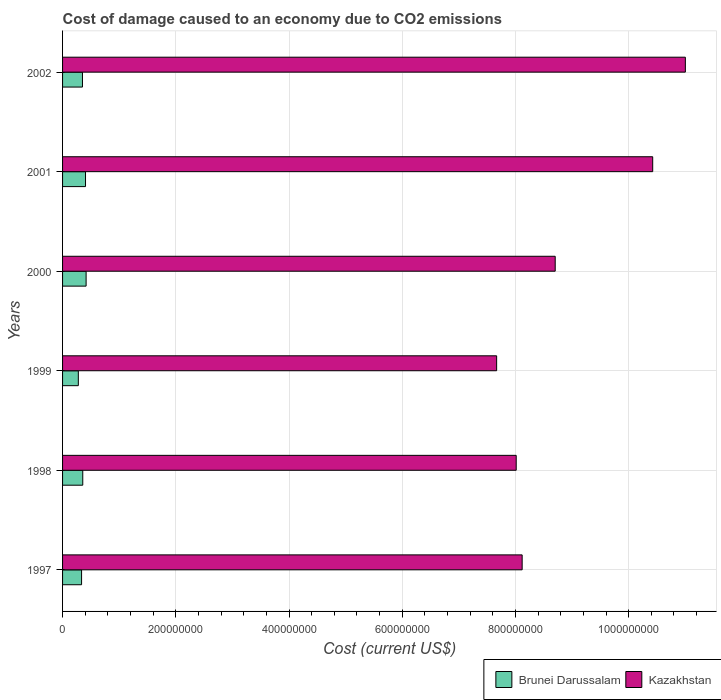How many different coloured bars are there?
Keep it short and to the point. 2. Are the number of bars on each tick of the Y-axis equal?
Make the answer very short. Yes. How many bars are there on the 6th tick from the bottom?
Offer a very short reply. 2. What is the label of the 6th group of bars from the top?
Your answer should be very brief. 1997. In how many cases, is the number of bars for a given year not equal to the number of legend labels?
Offer a very short reply. 0. What is the cost of damage caused due to CO2 emissisons in Kazakhstan in 2002?
Ensure brevity in your answer.  1.10e+09. Across all years, what is the maximum cost of damage caused due to CO2 emissisons in Brunei Darussalam?
Provide a short and direct response. 4.16e+07. Across all years, what is the minimum cost of damage caused due to CO2 emissisons in Kazakhstan?
Ensure brevity in your answer.  7.67e+08. In which year was the cost of damage caused due to CO2 emissisons in Brunei Darussalam maximum?
Offer a very short reply. 2000. What is the total cost of damage caused due to CO2 emissisons in Kazakhstan in the graph?
Your response must be concise. 5.39e+09. What is the difference between the cost of damage caused due to CO2 emissisons in Kazakhstan in 2001 and that in 2002?
Ensure brevity in your answer.  -5.77e+07. What is the difference between the cost of damage caused due to CO2 emissisons in Kazakhstan in 2000 and the cost of damage caused due to CO2 emissisons in Brunei Darussalam in 1999?
Offer a very short reply. 8.42e+08. What is the average cost of damage caused due to CO2 emissisons in Kazakhstan per year?
Your response must be concise. 8.99e+08. In the year 2000, what is the difference between the cost of damage caused due to CO2 emissisons in Brunei Darussalam and cost of damage caused due to CO2 emissisons in Kazakhstan?
Offer a terse response. -8.29e+08. In how many years, is the cost of damage caused due to CO2 emissisons in Brunei Darussalam greater than 280000000 US$?
Ensure brevity in your answer.  0. What is the ratio of the cost of damage caused due to CO2 emissisons in Kazakhstan in 1998 to that in 2002?
Your response must be concise. 0.73. Is the cost of damage caused due to CO2 emissisons in Brunei Darussalam in 1997 less than that in 2001?
Provide a short and direct response. Yes. What is the difference between the highest and the second highest cost of damage caused due to CO2 emissisons in Kazakhstan?
Offer a very short reply. 5.77e+07. What is the difference between the highest and the lowest cost of damage caused due to CO2 emissisons in Kazakhstan?
Your response must be concise. 3.33e+08. In how many years, is the cost of damage caused due to CO2 emissisons in Brunei Darussalam greater than the average cost of damage caused due to CO2 emissisons in Brunei Darussalam taken over all years?
Offer a very short reply. 2. Is the sum of the cost of damage caused due to CO2 emissisons in Brunei Darussalam in 1997 and 1998 greater than the maximum cost of damage caused due to CO2 emissisons in Kazakhstan across all years?
Give a very brief answer. No. What does the 2nd bar from the top in 1998 represents?
Your response must be concise. Brunei Darussalam. What does the 2nd bar from the bottom in 2000 represents?
Ensure brevity in your answer.  Kazakhstan. How many legend labels are there?
Provide a short and direct response. 2. What is the title of the graph?
Your answer should be very brief. Cost of damage caused to an economy due to CO2 emissions. What is the label or title of the X-axis?
Provide a short and direct response. Cost (current US$). What is the label or title of the Y-axis?
Your answer should be very brief. Years. What is the Cost (current US$) of Brunei Darussalam in 1997?
Provide a succinct answer. 3.36e+07. What is the Cost (current US$) of Kazakhstan in 1997?
Your response must be concise. 8.12e+08. What is the Cost (current US$) of Brunei Darussalam in 1998?
Your answer should be compact. 3.57e+07. What is the Cost (current US$) of Kazakhstan in 1998?
Provide a succinct answer. 8.01e+08. What is the Cost (current US$) of Brunei Darussalam in 1999?
Offer a terse response. 2.79e+07. What is the Cost (current US$) in Kazakhstan in 1999?
Provide a short and direct response. 7.67e+08. What is the Cost (current US$) in Brunei Darussalam in 2000?
Your answer should be compact. 4.16e+07. What is the Cost (current US$) of Kazakhstan in 2000?
Keep it short and to the point. 8.70e+08. What is the Cost (current US$) in Brunei Darussalam in 2001?
Give a very brief answer. 4.05e+07. What is the Cost (current US$) in Kazakhstan in 2001?
Provide a short and direct response. 1.04e+09. What is the Cost (current US$) in Brunei Darussalam in 2002?
Give a very brief answer. 3.52e+07. What is the Cost (current US$) of Kazakhstan in 2002?
Offer a terse response. 1.10e+09. Across all years, what is the maximum Cost (current US$) of Brunei Darussalam?
Your answer should be very brief. 4.16e+07. Across all years, what is the maximum Cost (current US$) in Kazakhstan?
Ensure brevity in your answer.  1.10e+09. Across all years, what is the minimum Cost (current US$) of Brunei Darussalam?
Keep it short and to the point. 2.79e+07. Across all years, what is the minimum Cost (current US$) in Kazakhstan?
Ensure brevity in your answer.  7.67e+08. What is the total Cost (current US$) in Brunei Darussalam in the graph?
Give a very brief answer. 2.14e+08. What is the total Cost (current US$) in Kazakhstan in the graph?
Offer a very short reply. 5.39e+09. What is the difference between the Cost (current US$) of Brunei Darussalam in 1997 and that in 1998?
Ensure brevity in your answer.  -2.10e+06. What is the difference between the Cost (current US$) of Kazakhstan in 1997 and that in 1998?
Your answer should be very brief. 1.05e+07. What is the difference between the Cost (current US$) in Brunei Darussalam in 1997 and that in 1999?
Offer a very short reply. 5.73e+06. What is the difference between the Cost (current US$) of Kazakhstan in 1997 and that in 1999?
Your answer should be compact. 4.51e+07. What is the difference between the Cost (current US$) in Brunei Darussalam in 1997 and that in 2000?
Offer a very short reply. -8.00e+06. What is the difference between the Cost (current US$) in Kazakhstan in 1997 and that in 2000?
Offer a very short reply. -5.84e+07. What is the difference between the Cost (current US$) of Brunei Darussalam in 1997 and that in 2001?
Make the answer very short. -6.96e+06. What is the difference between the Cost (current US$) in Kazakhstan in 1997 and that in 2001?
Ensure brevity in your answer.  -2.31e+08. What is the difference between the Cost (current US$) in Brunei Darussalam in 1997 and that in 2002?
Make the answer very short. -1.56e+06. What is the difference between the Cost (current US$) of Kazakhstan in 1997 and that in 2002?
Your answer should be compact. -2.88e+08. What is the difference between the Cost (current US$) in Brunei Darussalam in 1998 and that in 1999?
Give a very brief answer. 7.84e+06. What is the difference between the Cost (current US$) in Kazakhstan in 1998 and that in 1999?
Your answer should be compact. 3.46e+07. What is the difference between the Cost (current US$) in Brunei Darussalam in 1998 and that in 2000?
Provide a succinct answer. -5.89e+06. What is the difference between the Cost (current US$) of Kazakhstan in 1998 and that in 2000?
Provide a short and direct response. -6.89e+07. What is the difference between the Cost (current US$) in Brunei Darussalam in 1998 and that in 2001?
Provide a succinct answer. -4.86e+06. What is the difference between the Cost (current US$) in Kazakhstan in 1998 and that in 2001?
Your answer should be very brief. -2.41e+08. What is the difference between the Cost (current US$) in Brunei Darussalam in 1998 and that in 2002?
Offer a very short reply. 5.39e+05. What is the difference between the Cost (current US$) of Kazakhstan in 1998 and that in 2002?
Provide a short and direct response. -2.99e+08. What is the difference between the Cost (current US$) in Brunei Darussalam in 1999 and that in 2000?
Provide a succinct answer. -1.37e+07. What is the difference between the Cost (current US$) of Kazakhstan in 1999 and that in 2000?
Provide a short and direct response. -1.03e+08. What is the difference between the Cost (current US$) in Brunei Darussalam in 1999 and that in 2001?
Make the answer very short. -1.27e+07. What is the difference between the Cost (current US$) of Kazakhstan in 1999 and that in 2001?
Make the answer very short. -2.76e+08. What is the difference between the Cost (current US$) of Brunei Darussalam in 1999 and that in 2002?
Your response must be concise. -7.30e+06. What is the difference between the Cost (current US$) of Kazakhstan in 1999 and that in 2002?
Offer a very short reply. -3.33e+08. What is the difference between the Cost (current US$) in Brunei Darussalam in 2000 and that in 2001?
Your response must be concise. 1.03e+06. What is the difference between the Cost (current US$) in Kazakhstan in 2000 and that in 2001?
Make the answer very short. -1.72e+08. What is the difference between the Cost (current US$) in Brunei Darussalam in 2000 and that in 2002?
Offer a very short reply. 6.43e+06. What is the difference between the Cost (current US$) in Kazakhstan in 2000 and that in 2002?
Ensure brevity in your answer.  -2.30e+08. What is the difference between the Cost (current US$) of Brunei Darussalam in 2001 and that in 2002?
Give a very brief answer. 5.40e+06. What is the difference between the Cost (current US$) of Kazakhstan in 2001 and that in 2002?
Your answer should be very brief. -5.77e+07. What is the difference between the Cost (current US$) in Brunei Darussalam in 1997 and the Cost (current US$) in Kazakhstan in 1998?
Your answer should be compact. -7.68e+08. What is the difference between the Cost (current US$) in Brunei Darussalam in 1997 and the Cost (current US$) in Kazakhstan in 1999?
Offer a very short reply. -7.33e+08. What is the difference between the Cost (current US$) of Brunei Darussalam in 1997 and the Cost (current US$) of Kazakhstan in 2000?
Your answer should be very brief. -8.37e+08. What is the difference between the Cost (current US$) of Brunei Darussalam in 1997 and the Cost (current US$) of Kazakhstan in 2001?
Your response must be concise. -1.01e+09. What is the difference between the Cost (current US$) in Brunei Darussalam in 1997 and the Cost (current US$) in Kazakhstan in 2002?
Provide a short and direct response. -1.07e+09. What is the difference between the Cost (current US$) of Brunei Darussalam in 1998 and the Cost (current US$) of Kazakhstan in 1999?
Make the answer very short. -7.31e+08. What is the difference between the Cost (current US$) of Brunei Darussalam in 1998 and the Cost (current US$) of Kazakhstan in 2000?
Offer a very short reply. -8.35e+08. What is the difference between the Cost (current US$) of Brunei Darussalam in 1998 and the Cost (current US$) of Kazakhstan in 2001?
Make the answer very short. -1.01e+09. What is the difference between the Cost (current US$) in Brunei Darussalam in 1998 and the Cost (current US$) in Kazakhstan in 2002?
Your answer should be compact. -1.06e+09. What is the difference between the Cost (current US$) in Brunei Darussalam in 1999 and the Cost (current US$) in Kazakhstan in 2000?
Your answer should be very brief. -8.42e+08. What is the difference between the Cost (current US$) of Brunei Darussalam in 1999 and the Cost (current US$) of Kazakhstan in 2001?
Make the answer very short. -1.01e+09. What is the difference between the Cost (current US$) in Brunei Darussalam in 1999 and the Cost (current US$) in Kazakhstan in 2002?
Your response must be concise. -1.07e+09. What is the difference between the Cost (current US$) in Brunei Darussalam in 2000 and the Cost (current US$) in Kazakhstan in 2001?
Your answer should be compact. -1.00e+09. What is the difference between the Cost (current US$) in Brunei Darussalam in 2000 and the Cost (current US$) in Kazakhstan in 2002?
Provide a short and direct response. -1.06e+09. What is the difference between the Cost (current US$) in Brunei Darussalam in 2001 and the Cost (current US$) in Kazakhstan in 2002?
Your response must be concise. -1.06e+09. What is the average Cost (current US$) in Brunei Darussalam per year?
Offer a terse response. 3.57e+07. What is the average Cost (current US$) in Kazakhstan per year?
Your answer should be very brief. 8.99e+08. In the year 1997, what is the difference between the Cost (current US$) in Brunei Darussalam and Cost (current US$) in Kazakhstan?
Provide a short and direct response. -7.78e+08. In the year 1998, what is the difference between the Cost (current US$) of Brunei Darussalam and Cost (current US$) of Kazakhstan?
Give a very brief answer. -7.66e+08. In the year 1999, what is the difference between the Cost (current US$) in Brunei Darussalam and Cost (current US$) in Kazakhstan?
Ensure brevity in your answer.  -7.39e+08. In the year 2000, what is the difference between the Cost (current US$) in Brunei Darussalam and Cost (current US$) in Kazakhstan?
Your answer should be compact. -8.29e+08. In the year 2001, what is the difference between the Cost (current US$) of Brunei Darussalam and Cost (current US$) of Kazakhstan?
Provide a succinct answer. -1.00e+09. In the year 2002, what is the difference between the Cost (current US$) in Brunei Darussalam and Cost (current US$) in Kazakhstan?
Keep it short and to the point. -1.06e+09. What is the ratio of the Cost (current US$) in Brunei Darussalam in 1997 to that in 1998?
Offer a terse response. 0.94. What is the ratio of the Cost (current US$) of Kazakhstan in 1997 to that in 1998?
Your answer should be compact. 1.01. What is the ratio of the Cost (current US$) in Brunei Darussalam in 1997 to that in 1999?
Your answer should be compact. 1.21. What is the ratio of the Cost (current US$) of Kazakhstan in 1997 to that in 1999?
Provide a short and direct response. 1.06. What is the ratio of the Cost (current US$) of Brunei Darussalam in 1997 to that in 2000?
Offer a terse response. 0.81. What is the ratio of the Cost (current US$) in Kazakhstan in 1997 to that in 2000?
Your answer should be compact. 0.93. What is the ratio of the Cost (current US$) of Brunei Darussalam in 1997 to that in 2001?
Your answer should be compact. 0.83. What is the ratio of the Cost (current US$) in Kazakhstan in 1997 to that in 2001?
Your answer should be very brief. 0.78. What is the ratio of the Cost (current US$) in Brunei Darussalam in 1997 to that in 2002?
Offer a very short reply. 0.96. What is the ratio of the Cost (current US$) in Kazakhstan in 1997 to that in 2002?
Your answer should be compact. 0.74. What is the ratio of the Cost (current US$) of Brunei Darussalam in 1998 to that in 1999?
Your response must be concise. 1.28. What is the ratio of the Cost (current US$) in Kazakhstan in 1998 to that in 1999?
Provide a succinct answer. 1.05. What is the ratio of the Cost (current US$) in Brunei Darussalam in 1998 to that in 2000?
Provide a succinct answer. 0.86. What is the ratio of the Cost (current US$) in Kazakhstan in 1998 to that in 2000?
Provide a short and direct response. 0.92. What is the ratio of the Cost (current US$) in Brunei Darussalam in 1998 to that in 2001?
Your answer should be very brief. 0.88. What is the ratio of the Cost (current US$) of Kazakhstan in 1998 to that in 2001?
Ensure brevity in your answer.  0.77. What is the ratio of the Cost (current US$) of Brunei Darussalam in 1998 to that in 2002?
Your answer should be compact. 1.02. What is the ratio of the Cost (current US$) in Kazakhstan in 1998 to that in 2002?
Keep it short and to the point. 0.73. What is the ratio of the Cost (current US$) in Brunei Darussalam in 1999 to that in 2000?
Offer a terse response. 0.67. What is the ratio of the Cost (current US$) of Kazakhstan in 1999 to that in 2000?
Your answer should be very brief. 0.88. What is the ratio of the Cost (current US$) of Brunei Darussalam in 1999 to that in 2001?
Offer a very short reply. 0.69. What is the ratio of the Cost (current US$) of Kazakhstan in 1999 to that in 2001?
Keep it short and to the point. 0.74. What is the ratio of the Cost (current US$) of Brunei Darussalam in 1999 to that in 2002?
Provide a succinct answer. 0.79. What is the ratio of the Cost (current US$) in Kazakhstan in 1999 to that in 2002?
Your answer should be compact. 0.7. What is the ratio of the Cost (current US$) in Brunei Darussalam in 2000 to that in 2001?
Ensure brevity in your answer.  1.03. What is the ratio of the Cost (current US$) of Kazakhstan in 2000 to that in 2001?
Keep it short and to the point. 0.83. What is the ratio of the Cost (current US$) of Brunei Darussalam in 2000 to that in 2002?
Your answer should be compact. 1.18. What is the ratio of the Cost (current US$) of Kazakhstan in 2000 to that in 2002?
Keep it short and to the point. 0.79. What is the ratio of the Cost (current US$) in Brunei Darussalam in 2001 to that in 2002?
Your answer should be compact. 1.15. What is the ratio of the Cost (current US$) of Kazakhstan in 2001 to that in 2002?
Offer a terse response. 0.95. What is the difference between the highest and the second highest Cost (current US$) of Brunei Darussalam?
Give a very brief answer. 1.03e+06. What is the difference between the highest and the second highest Cost (current US$) of Kazakhstan?
Ensure brevity in your answer.  5.77e+07. What is the difference between the highest and the lowest Cost (current US$) in Brunei Darussalam?
Keep it short and to the point. 1.37e+07. What is the difference between the highest and the lowest Cost (current US$) in Kazakhstan?
Keep it short and to the point. 3.33e+08. 